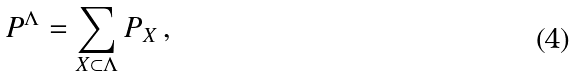<formula> <loc_0><loc_0><loc_500><loc_500>P ^ { \Lambda } = \sum _ { X \subset \Lambda } P _ { X } \, ,</formula> 